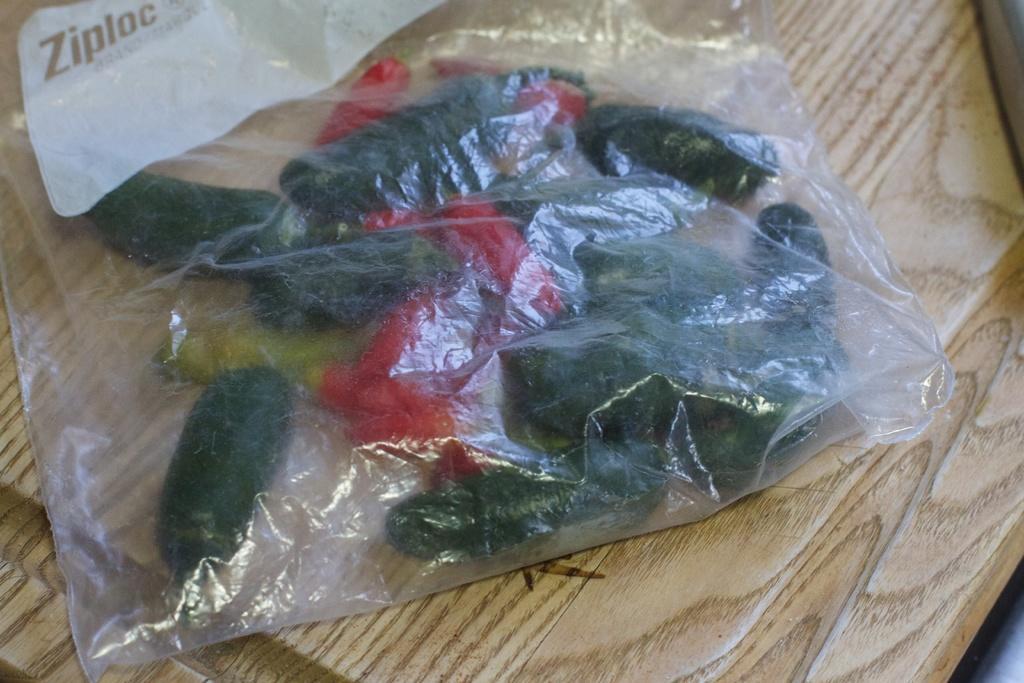Please provide a concise description of this image. In this picture we can see cover with vegetables on the wooden surface. 